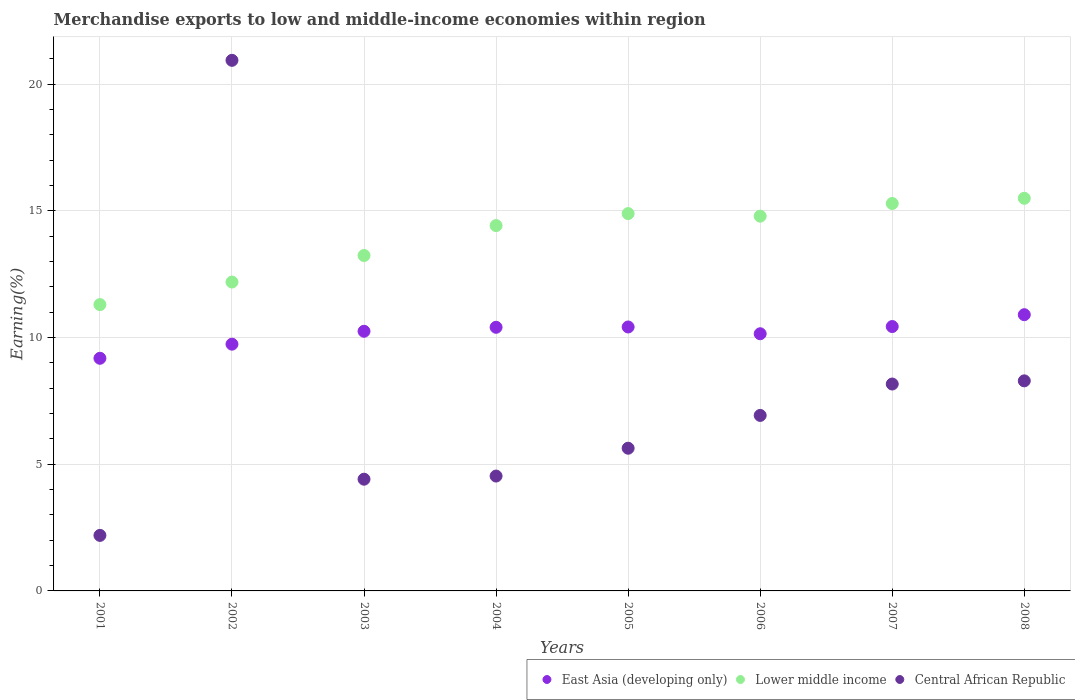How many different coloured dotlines are there?
Offer a terse response. 3. What is the percentage of amount earned from merchandise exports in Central African Republic in 2007?
Your answer should be very brief. 8.17. Across all years, what is the maximum percentage of amount earned from merchandise exports in East Asia (developing only)?
Give a very brief answer. 10.9. Across all years, what is the minimum percentage of amount earned from merchandise exports in East Asia (developing only)?
Provide a short and direct response. 9.18. What is the total percentage of amount earned from merchandise exports in Lower middle income in the graph?
Offer a very short reply. 111.63. What is the difference between the percentage of amount earned from merchandise exports in Lower middle income in 2006 and that in 2007?
Provide a succinct answer. -0.5. What is the difference between the percentage of amount earned from merchandise exports in Central African Republic in 2004 and the percentage of amount earned from merchandise exports in East Asia (developing only) in 2007?
Your answer should be very brief. -5.9. What is the average percentage of amount earned from merchandise exports in Central African Republic per year?
Your answer should be very brief. 7.64. In the year 2006, what is the difference between the percentage of amount earned from merchandise exports in Central African Republic and percentage of amount earned from merchandise exports in Lower middle income?
Make the answer very short. -7.87. In how many years, is the percentage of amount earned from merchandise exports in East Asia (developing only) greater than 20 %?
Offer a terse response. 0. What is the ratio of the percentage of amount earned from merchandise exports in Lower middle income in 2006 to that in 2008?
Ensure brevity in your answer.  0.95. What is the difference between the highest and the second highest percentage of amount earned from merchandise exports in East Asia (developing only)?
Your answer should be very brief. 0.47. What is the difference between the highest and the lowest percentage of amount earned from merchandise exports in Lower middle income?
Your answer should be compact. 4.2. In how many years, is the percentage of amount earned from merchandise exports in Central African Republic greater than the average percentage of amount earned from merchandise exports in Central African Republic taken over all years?
Offer a very short reply. 3. Is the percentage of amount earned from merchandise exports in Central African Republic strictly less than the percentage of amount earned from merchandise exports in East Asia (developing only) over the years?
Make the answer very short. No. How many dotlines are there?
Ensure brevity in your answer.  3. How many years are there in the graph?
Your answer should be compact. 8. What is the title of the graph?
Make the answer very short. Merchandise exports to low and middle-income economies within region. What is the label or title of the X-axis?
Give a very brief answer. Years. What is the label or title of the Y-axis?
Your response must be concise. Earning(%). What is the Earning(%) in East Asia (developing only) in 2001?
Provide a succinct answer. 9.18. What is the Earning(%) of Lower middle income in 2001?
Your response must be concise. 11.3. What is the Earning(%) in Central African Republic in 2001?
Ensure brevity in your answer.  2.19. What is the Earning(%) in East Asia (developing only) in 2002?
Your response must be concise. 9.74. What is the Earning(%) of Lower middle income in 2002?
Keep it short and to the point. 12.19. What is the Earning(%) in Central African Republic in 2002?
Provide a succinct answer. 20.94. What is the Earning(%) in East Asia (developing only) in 2003?
Your answer should be compact. 10.25. What is the Earning(%) in Lower middle income in 2003?
Offer a terse response. 13.24. What is the Earning(%) in Central African Republic in 2003?
Your answer should be compact. 4.41. What is the Earning(%) in East Asia (developing only) in 2004?
Ensure brevity in your answer.  10.41. What is the Earning(%) in Lower middle income in 2004?
Make the answer very short. 14.42. What is the Earning(%) in Central African Republic in 2004?
Your response must be concise. 4.53. What is the Earning(%) of East Asia (developing only) in 2005?
Give a very brief answer. 10.42. What is the Earning(%) in Lower middle income in 2005?
Your response must be concise. 14.89. What is the Earning(%) in Central African Republic in 2005?
Your response must be concise. 5.63. What is the Earning(%) in East Asia (developing only) in 2006?
Offer a terse response. 10.15. What is the Earning(%) in Lower middle income in 2006?
Your response must be concise. 14.79. What is the Earning(%) of Central African Republic in 2006?
Your answer should be very brief. 6.93. What is the Earning(%) in East Asia (developing only) in 2007?
Offer a very short reply. 10.44. What is the Earning(%) in Lower middle income in 2007?
Give a very brief answer. 15.29. What is the Earning(%) in Central African Republic in 2007?
Keep it short and to the point. 8.17. What is the Earning(%) in East Asia (developing only) in 2008?
Give a very brief answer. 10.9. What is the Earning(%) of Lower middle income in 2008?
Keep it short and to the point. 15.5. What is the Earning(%) in Central African Republic in 2008?
Provide a succinct answer. 8.29. Across all years, what is the maximum Earning(%) of East Asia (developing only)?
Offer a terse response. 10.9. Across all years, what is the maximum Earning(%) in Lower middle income?
Provide a short and direct response. 15.5. Across all years, what is the maximum Earning(%) in Central African Republic?
Make the answer very short. 20.94. Across all years, what is the minimum Earning(%) in East Asia (developing only)?
Provide a succinct answer. 9.18. Across all years, what is the minimum Earning(%) of Lower middle income?
Provide a short and direct response. 11.3. Across all years, what is the minimum Earning(%) of Central African Republic?
Ensure brevity in your answer.  2.19. What is the total Earning(%) of East Asia (developing only) in the graph?
Your answer should be very brief. 81.49. What is the total Earning(%) of Lower middle income in the graph?
Give a very brief answer. 111.63. What is the total Earning(%) in Central African Republic in the graph?
Provide a succinct answer. 61.1. What is the difference between the Earning(%) in East Asia (developing only) in 2001 and that in 2002?
Your answer should be compact. -0.56. What is the difference between the Earning(%) of Lower middle income in 2001 and that in 2002?
Make the answer very short. -0.89. What is the difference between the Earning(%) in Central African Republic in 2001 and that in 2002?
Your response must be concise. -18.75. What is the difference between the Earning(%) of East Asia (developing only) in 2001 and that in 2003?
Provide a succinct answer. -1.07. What is the difference between the Earning(%) in Lower middle income in 2001 and that in 2003?
Offer a terse response. -1.94. What is the difference between the Earning(%) in Central African Republic in 2001 and that in 2003?
Offer a terse response. -2.22. What is the difference between the Earning(%) in East Asia (developing only) in 2001 and that in 2004?
Give a very brief answer. -1.22. What is the difference between the Earning(%) in Lower middle income in 2001 and that in 2004?
Ensure brevity in your answer.  -3.12. What is the difference between the Earning(%) in Central African Republic in 2001 and that in 2004?
Your answer should be very brief. -2.34. What is the difference between the Earning(%) in East Asia (developing only) in 2001 and that in 2005?
Ensure brevity in your answer.  -1.24. What is the difference between the Earning(%) of Lower middle income in 2001 and that in 2005?
Offer a very short reply. -3.59. What is the difference between the Earning(%) in Central African Republic in 2001 and that in 2005?
Your answer should be very brief. -3.44. What is the difference between the Earning(%) of East Asia (developing only) in 2001 and that in 2006?
Provide a short and direct response. -0.97. What is the difference between the Earning(%) of Lower middle income in 2001 and that in 2006?
Give a very brief answer. -3.49. What is the difference between the Earning(%) in Central African Republic in 2001 and that in 2006?
Your response must be concise. -4.74. What is the difference between the Earning(%) in East Asia (developing only) in 2001 and that in 2007?
Your answer should be compact. -1.25. What is the difference between the Earning(%) in Lower middle income in 2001 and that in 2007?
Your answer should be very brief. -3.99. What is the difference between the Earning(%) in Central African Republic in 2001 and that in 2007?
Provide a short and direct response. -5.97. What is the difference between the Earning(%) in East Asia (developing only) in 2001 and that in 2008?
Offer a very short reply. -1.72. What is the difference between the Earning(%) of Lower middle income in 2001 and that in 2008?
Ensure brevity in your answer.  -4.2. What is the difference between the Earning(%) of Central African Republic in 2001 and that in 2008?
Provide a short and direct response. -6.1. What is the difference between the Earning(%) in East Asia (developing only) in 2002 and that in 2003?
Provide a succinct answer. -0.51. What is the difference between the Earning(%) of Lower middle income in 2002 and that in 2003?
Provide a short and direct response. -1.05. What is the difference between the Earning(%) of Central African Republic in 2002 and that in 2003?
Make the answer very short. 16.53. What is the difference between the Earning(%) of East Asia (developing only) in 2002 and that in 2004?
Offer a terse response. -0.67. What is the difference between the Earning(%) of Lower middle income in 2002 and that in 2004?
Your answer should be compact. -2.23. What is the difference between the Earning(%) in Central African Republic in 2002 and that in 2004?
Provide a short and direct response. 16.41. What is the difference between the Earning(%) of East Asia (developing only) in 2002 and that in 2005?
Give a very brief answer. -0.68. What is the difference between the Earning(%) of Lower middle income in 2002 and that in 2005?
Provide a short and direct response. -2.7. What is the difference between the Earning(%) of Central African Republic in 2002 and that in 2005?
Provide a short and direct response. 15.31. What is the difference between the Earning(%) in East Asia (developing only) in 2002 and that in 2006?
Your response must be concise. -0.41. What is the difference between the Earning(%) in Lower middle income in 2002 and that in 2006?
Offer a very short reply. -2.6. What is the difference between the Earning(%) of Central African Republic in 2002 and that in 2006?
Ensure brevity in your answer.  14.02. What is the difference between the Earning(%) in East Asia (developing only) in 2002 and that in 2007?
Offer a terse response. -0.7. What is the difference between the Earning(%) of Lower middle income in 2002 and that in 2007?
Give a very brief answer. -3.1. What is the difference between the Earning(%) of Central African Republic in 2002 and that in 2007?
Ensure brevity in your answer.  12.78. What is the difference between the Earning(%) in East Asia (developing only) in 2002 and that in 2008?
Your answer should be compact. -1.16. What is the difference between the Earning(%) of Lower middle income in 2002 and that in 2008?
Your response must be concise. -3.31. What is the difference between the Earning(%) of Central African Republic in 2002 and that in 2008?
Your answer should be compact. 12.65. What is the difference between the Earning(%) of East Asia (developing only) in 2003 and that in 2004?
Provide a short and direct response. -0.16. What is the difference between the Earning(%) in Lower middle income in 2003 and that in 2004?
Ensure brevity in your answer.  -1.18. What is the difference between the Earning(%) of Central African Republic in 2003 and that in 2004?
Your response must be concise. -0.12. What is the difference between the Earning(%) of East Asia (developing only) in 2003 and that in 2005?
Provide a succinct answer. -0.17. What is the difference between the Earning(%) in Lower middle income in 2003 and that in 2005?
Ensure brevity in your answer.  -1.65. What is the difference between the Earning(%) in Central African Republic in 2003 and that in 2005?
Your answer should be compact. -1.22. What is the difference between the Earning(%) in East Asia (developing only) in 2003 and that in 2006?
Keep it short and to the point. 0.1. What is the difference between the Earning(%) of Lower middle income in 2003 and that in 2006?
Offer a very short reply. -1.55. What is the difference between the Earning(%) in Central African Republic in 2003 and that in 2006?
Make the answer very short. -2.52. What is the difference between the Earning(%) of East Asia (developing only) in 2003 and that in 2007?
Provide a short and direct response. -0.19. What is the difference between the Earning(%) in Lower middle income in 2003 and that in 2007?
Offer a terse response. -2.05. What is the difference between the Earning(%) of Central African Republic in 2003 and that in 2007?
Provide a succinct answer. -3.76. What is the difference between the Earning(%) of East Asia (developing only) in 2003 and that in 2008?
Provide a succinct answer. -0.65. What is the difference between the Earning(%) in Lower middle income in 2003 and that in 2008?
Offer a terse response. -2.26. What is the difference between the Earning(%) of Central African Republic in 2003 and that in 2008?
Make the answer very short. -3.88. What is the difference between the Earning(%) of East Asia (developing only) in 2004 and that in 2005?
Offer a very short reply. -0.01. What is the difference between the Earning(%) of Lower middle income in 2004 and that in 2005?
Offer a terse response. -0.47. What is the difference between the Earning(%) of Central African Republic in 2004 and that in 2005?
Provide a short and direct response. -1.1. What is the difference between the Earning(%) of East Asia (developing only) in 2004 and that in 2006?
Provide a short and direct response. 0.25. What is the difference between the Earning(%) of Lower middle income in 2004 and that in 2006?
Make the answer very short. -0.37. What is the difference between the Earning(%) in Central African Republic in 2004 and that in 2006?
Your response must be concise. -2.39. What is the difference between the Earning(%) in East Asia (developing only) in 2004 and that in 2007?
Ensure brevity in your answer.  -0.03. What is the difference between the Earning(%) of Lower middle income in 2004 and that in 2007?
Ensure brevity in your answer.  -0.87. What is the difference between the Earning(%) of Central African Republic in 2004 and that in 2007?
Keep it short and to the point. -3.63. What is the difference between the Earning(%) in East Asia (developing only) in 2004 and that in 2008?
Offer a very short reply. -0.5. What is the difference between the Earning(%) of Lower middle income in 2004 and that in 2008?
Provide a succinct answer. -1.08. What is the difference between the Earning(%) of Central African Republic in 2004 and that in 2008?
Your answer should be very brief. -3.76. What is the difference between the Earning(%) in East Asia (developing only) in 2005 and that in 2006?
Offer a very short reply. 0.27. What is the difference between the Earning(%) of Lower middle income in 2005 and that in 2006?
Make the answer very short. 0.1. What is the difference between the Earning(%) in Central African Republic in 2005 and that in 2006?
Provide a succinct answer. -1.29. What is the difference between the Earning(%) of East Asia (developing only) in 2005 and that in 2007?
Ensure brevity in your answer.  -0.02. What is the difference between the Earning(%) of Lower middle income in 2005 and that in 2007?
Keep it short and to the point. -0.4. What is the difference between the Earning(%) of Central African Republic in 2005 and that in 2007?
Your response must be concise. -2.53. What is the difference between the Earning(%) of East Asia (developing only) in 2005 and that in 2008?
Provide a short and direct response. -0.48. What is the difference between the Earning(%) in Lower middle income in 2005 and that in 2008?
Provide a succinct answer. -0.6. What is the difference between the Earning(%) in Central African Republic in 2005 and that in 2008?
Your response must be concise. -2.66. What is the difference between the Earning(%) in East Asia (developing only) in 2006 and that in 2007?
Your response must be concise. -0.28. What is the difference between the Earning(%) of Lower middle income in 2006 and that in 2007?
Offer a terse response. -0.5. What is the difference between the Earning(%) in Central African Republic in 2006 and that in 2007?
Provide a short and direct response. -1.24. What is the difference between the Earning(%) of East Asia (developing only) in 2006 and that in 2008?
Offer a terse response. -0.75. What is the difference between the Earning(%) of Lower middle income in 2006 and that in 2008?
Ensure brevity in your answer.  -0.71. What is the difference between the Earning(%) in Central African Republic in 2006 and that in 2008?
Offer a very short reply. -1.36. What is the difference between the Earning(%) in East Asia (developing only) in 2007 and that in 2008?
Provide a succinct answer. -0.47. What is the difference between the Earning(%) of Lower middle income in 2007 and that in 2008?
Ensure brevity in your answer.  -0.21. What is the difference between the Earning(%) in Central African Republic in 2007 and that in 2008?
Give a very brief answer. -0.13. What is the difference between the Earning(%) in East Asia (developing only) in 2001 and the Earning(%) in Lower middle income in 2002?
Your answer should be compact. -3.01. What is the difference between the Earning(%) in East Asia (developing only) in 2001 and the Earning(%) in Central African Republic in 2002?
Give a very brief answer. -11.76. What is the difference between the Earning(%) in Lower middle income in 2001 and the Earning(%) in Central African Republic in 2002?
Offer a terse response. -9.64. What is the difference between the Earning(%) of East Asia (developing only) in 2001 and the Earning(%) of Lower middle income in 2003?
Make the answer very short. -4.06. What is the difference between the Earning(%) in East Asia (developing only) in 2001 and the Earning(%) in Central African Republic in 2003?
Make the answer very short. 4.77. What is the difference between the Earning(%) of Lower middle income in 2001 and the Earning(%) of Central African Republic in 2003?
Ensure brevity in your answer.  6.89. What is the difference between the Earning(%) in East Asia (developing only) in 2001 and the Earning(%) in Lower middle income in 2004?
Keep it short and to the point. -5.24. What is the difference between the Earning(%) in East Asia (developing only) in 2001 and the Earning(%) in Central African Republic in 2004?
Offer a very short reply. 4.65. What is the difference between the Earning(%) in Lower middle income in 2001 and the Earning(%) in Central African Republic in 2004?
Provide a succinct answer. 6.77. What is the difference between the Earning(%) of East Asia (developing only) in 2001 and the Earning(%) of Lower middle income in 2005?
Provide a short and direct response. -5.71. What is the difference between the Earning(%) of East Asia (developing only) in 2001 and the Earning(%) of Central African Republic in 2005?
Provide a short and direct response. 3.55. What is the difference between the Earning(%) in Lower middle income in 2001 and the Earning(%) in Central African Republic in 2005?
Your response must be concise. 5.67. What is the difference between the Earning(%) in East Asia (developing only) in 2001 and the Earning(%) in Lower middle income in 2006?
Ensure brevity in your answer.  -5.61. What is the difference between the Earning(%) in East Asia (developing only) in 2001 and the Earning(%) in Central African Republic in 2006?
Give a very brief answer. 2.26. What is the difference between the Earning(%) of Lower middle income in 2001 and the Earning(%) of Central African Republic in 2006?
Your response must be concise. 4.37. What is the difference between the Earning(%) of East Asia (developing only) in 2001 and the Earning(%) of Lower middle income in 2007?
Your response must be concise. -6.11. What is the difference between the Earning(%) in East Asia (developing only) in 2001 and the Earning(%) in Central African Republic in 2007?
Offer a terse response. 1.02. What is the difference between the Earning(%) of Lower middle income in 2001 and the Earning(%) of Central African Republic in 2007?
Your answer should be compact. 3.14. What is the difference between the Earning(%) in East Asia (developing only) in 2001 and the Earning(%) in Lower middle income in 2008?
Ensure brevity in your answer.  -6.32. What is the difference between the Earning(%) of East Asia (developing only) in 2001 and the Earning(%) of Central African Republic in 2008?
Your answer should be compact. 0.89. What is the difference between the Earning(%) in Lower middle income in 2001 and the Earning(%) in Central African Republic in 2008?
Offer a very short reply. 3.01. What is the difference between the Earning(%) of East Asia (developing only) in 2002 and the Earning(%) of Lower middle income in 2003?
Make the answer very short. -3.5. What is the difference between the Earning(%) in East Asia (developing only) in 2002 and the Earning(%) in Central African Republic in 2003?
Ensure brevity in your answer.  5.33. What is the difference between the Earning(%) of Lower middle income in 2002 and the Earning(%) of Central African Republic in 2003?
Your response must be concise. 7.78. What is the difference between the Earning(%) of East Asia (developing only) in 2002 and the Earning(%) of Lower middle income in 2004?
Your response must be concise. -4.68. What is the difference between the Earning(%) in East Asia (developing only) in 2002 and the Earning(%) in Central African Republic in 2004?
Offer a very short reply. 5.21. What is the difference between the Earning(%) of Lower middle income in 2002 and the Earning(%) of Central African Republic in 2004?
Offer a very short reply. 7.66. What is the difference between the Earning(%) of East Asia (developing only) in 2002 and the Earning(%) of Lower middle income in 2005?
Offer a very short reply. -5.15. What is the difference between the Earning(%) in East Asia (developing only) in 2002 and the Earning(%) in Central African Republic in 2005?
Make the answer very short. 4.11. What is the difference between the Earning(%) of Lower middle income in 2002 and the Earning(%) of Central African Republic in 2005?
Provide a short and direct response. 6.56. What is the difference between the Earning(%) of East Asia (developing only) in 2002 and the Earning(%) of Lower middle income in 2006?
Your answer should be compact. -5.05. What is the difference between the Earning(%) in East Asia (developing only) in 2002 and the Earning(%) in Central African Republic in 2006?
Keep it short and to the point. 2.81. What is the difference between the Earning(%) of Lower middle income in 2002 and the Earning(%) of Central African Republic in 2006?
Your response must be concise. 5.26. What is the difference between the Earning(%) of East Asia (developing only) in 2002 and the Earning(%) of Lower middle income in 2007?
Keep it short and to the point. -5.55. What is the difference between the Earning(%) of East Asia (developing only) in 2002 and the Earning(%) of Central African Republic in 2007?
Ensure brevity in your answer.  1.57. What is the difference between the Earning(%) of Lower middle income in 2002 and the Earning(%) of Central African Republic in 2007?
Your response must be concise. 4.03. What is the difference between the Earning(%) of East Asia (developing only) in 2002 and the Earning(%) of Lower middle income in 2008?
Your answer should be compact. -5.76. What is the difference between the Earning(%) of East Asia (developing only) in 2002 and the Earning(%) of Central African Republic in 2008?
Offer a very short reply. 1.45. What is the difference between the Earning(%) in Lower middle income in 2002 and the Earning(%) in Central African Republic in 2008?
Provide a short and direct response. 3.9. What is the difference between the Earning(%) of East Asia (developing only) in 2003 and the Earning(%) of Lower middle income in 2004?
Keep it short and to the point. -4.17. What is the difference between the Earning(%) of East Asia (developing only) in 2003 and the Earning(%) of Central African Republic in 2004?
Offer a terse response. 5.72. What is the difference between the Earning(%) of Lower middle income in 2003 and the Earning(%) of Central African Republic in 2004?
Provide a short and direct response. 8.71. What is the difference between the Earning(%) in East Asia (developing only) in 2003 and the Earning(%) in Lower middle income in 2005?
Your answer should be very brief. -4.64. What is the difference between the Earning(%) of East Asia (developing only) in 2003 and the Earning(%) of Central African Republic in 2005?
Give a very brief answer. 4.62. What is the difference between the Earning(%) of Lower middle income in 2003 and the Earning(%) of Central African Republic in 2005?
Ensure brevity in your answer.  7.61. What is the difference between the Earning(%) in East Asia (developing only) in 2003 and the Earning(%) in Lower middle income in 2006?
Offer a terse response. -4.54. What is the difference between the Earning(%) in East Asia (developing only) in 2003 and the Earning(%) in Central African Republic in 2006?
Your answer should be very brief. 3.32. What is the difference between the Earning(%) in Lower middle income in 2003 and the Earning(%) in Central African Republic in 2006?
Your response must be concise. 6.31. What is the difference between the Earning(%) of East Asia (developing only) in 2003 and the Earning(%) of Lower middle income in 2007?
Give a very brief answer. -5.04. What is the difference between the Earning(%) in East Asia (developing only) in 2003 and the Earning(%) in Central African Republic in 2007?
Provide a short and direct response. 2.08. What is the difference between the Earning(%) in Lower middle income in 2003 and the Earning(%) in Central African Republic in 2007?
Your answer should be very brief. 5.07. What is the difference between the Earning(%) of East Asia (developing only) in 2003 and the Earning(%) of Lower middle income in 2008?
Keep it short and to the point. -5.25. What is the difference between the Earning(%) of East Asia (developing only) in 2003 and the Earning(%) of Central African Republic in 2008?
Ensure brevity in your answer.  1.96. What is the difference between the Earning(%) in Lower middle income in 2003 and the Earning(%) in Central African Republic in 2008?
Provide a succinct answer. 4.95. What is the difference between the Earning(%) in East Asia (developing only) in 2004 and the Earning(%) in Lower middle income in 2005?
Your answer should be very brief. -4.49. What is the difference between the Earning(%) in East Asia (developing only) in 2004 and the Earning(%) in Central African Republic in 2005?
Offer a terse response. 4.77. What is the difference between the Earning(%) of Lower middle income in 2004 and the Earning(%) of Central African Republic in 2005?
Keep it short and to the point. 8.79. What is the difference between the Earning(%) of East Asia (developing only) in 2004 and the Earning(%) of Lower middle income in 2006?
Provide a succinct answer. -4.39. What is the difference between the Earning(%) of East Asia (developing only) in 2004 and the Earning(%) of Central African Republic in 2006?
Ensure brevity in your answer.  3.48. What is the difference between the Earning(%) of Lower middle income in 2004 and the Earning(%) of Central African Republic in 2006?
Offer a very short reply. 7.49. What is the difference between the Earning(%) of East Asia (developing only) in 2004 and the Earning(%) of Lower middle income in 2007?
Your answer should be compact. -4.89. What is the difference between the Earning(%) of East Asia (developing only) in 2004 and the Earning(%) of Central African Republic in 2007?
Offer a terse response. 2.24. What is the difference between the Earning(%) in Lower middle income in 2004 and the Earning(%) in Central African Republic in 2007?
Your answer should be very brief. 6.25. What is the difference between the Earning(%) of East Asia (developing only) in 2004 and the Earning(%) of Lower middle income in 2008?
Give a very brief answer. -5.09. What is the difference between the Earning(%) in East Asia (developing only) in 2004 and the Earning(%) in Central African Republic in 2008?
Offer a very short reply. 2.11. What is the difference between the Earning(%) of Lower middle income in 2004 and the Earning(%) of Central African Republic in 2008?
Provide a succinct answer. 6.13. What is the difference between the Earning(%) of East Asia (developing only) in 2005 and the Earning(%) of Lower middle income in 2006?
Ensure brevity in your answer.  -4.37. What is the difference between the Earning(%) of East Asia (developing only) in 2005 and the Earning(%) of Central African Republic in 2006?
Your answer should be very brief. 3.49. What is the difference between the Earning(%) in Lower middle income in 2005 and the Earning(%) in Central African Republic in 2006?
Provide a short and direct response. 7.97. What is the difference between the Earning(%) of East Asia (developing only) in 2005 and the Earning(%) of Lower middle income in 2007?
Make the answer very short. -4.87. What is the difference between the Earning(%) of East Asia (developing only) in 2005 and the Earning(%) of Central African Republic in 2007?
Keep it short and to the point. 2.25. What is the difference between the Earning(%) of Lower middle income in 2005 and the Earning(%) of Central African Republic in 2007?
Offer a very short reply. 6.73. What is the difference between the Earning(%) in East Asia (developing only) in 2005 and the Earning(%) in Lower middle income in 2008?
Your response must be concise. -5.08. What is the difference between the Earning(%) in East Asia (developing only) in 2005 and the Earning(%) in Central African Republic in 2008?
Your answer should be very brief. 2.13. What is the difference between the Earning(%) in Lower middle income in 2005 and the Earning(%) in Central African Republic in 2008?
Your answer should be compact. 6.6. What is the difference between the Earning(%) of East Asia (developing only) in 2006 and the Earning(%) of Lower middle income in 2007?
Ensure brevity in your answer.  -5.14. What is the difference between the Earning(%) of East Asia (developing only) in 2006 and the Earning(%) of Central African Republic in 2007?
Your answer should be very brief. 1.98. What is the difference between the Earning(%) in Lower middle income in 2006 and the Earning(%) in Central African Republic in 2007?
Offer a terse response. 6.63. What is the difference between the Earning(%) in East Asia (developing only) in 2006 and the Earning(%) in Lower middle income in 2008?
Ensure brevity in your answer.  -5.35. What is the difference between the Earning(%) in East Asia (developing only) in 2006 and the Earning(%) in Central African Republic in 2008?
Provide a succinct answer. 1.86. What is the difference between the Earning(%) in Lower middle income in 2006 and the Earning(%) in Central African Republic in 2008?
Provide a short and direct response. 6.5. What is the difference between the Earning(%) in East Asia (developing only) in 2007 and the Earning(%) in Lower middle income in 2008?
Keep it short and to the point. -5.06. What is the difference between the Earning(%) in East Asia (developing only) in 2007 and the Earning(%) in Central African Republic in 2008?
Provide a succinct answer. 2.14. What is the difference between the Earning(%) in Lower middle income in 2007 and the Earning(%) in Central African Republic in 2008?
Provide a succinct answer. 7. What is the average Earning(%) in East Asia (developing only) per year?
Your answer should be very brief. 10.19. What is the average Earning(%) in Lower middle income per year?
Ensure brevity in your answer.  13.95. What is the average Earning(%) of Central African Republic per year?
Your response must be concise. 7.64. In the year 2001, what is the difference between the Earning(%) of East Asia (developing only) and Earning(%) of Lower middle income?
Your answer should be very brief. -2.12. In the year 2001, what is the difference between the Earning(%) of East Asia (developing only) and Earning(%) of Central African Republic?
Your answer should be very brief. 6.99. In the year 2001, what is the difference between the Earning(%) of Lower middle income and Earning(%) of Central African Republic?
Provide a succinct answer. 9.11. In the year 2002, what is the difference between the Earning(%) in East Asia (developing only) and Earning(%) in Lower middle income?
Offer a very short reply. -2.45. In the year 2002, what is the difference between the Earning(%) of East Asia (developing only) and Earning(%) of Central African Republic?
Ensure brevity in your answer.  -11.2. In the year 2002, what is the difference between the Earning(%) in Lower middle income and Earning(%) in Central African Republic?
Your answer should be compact. -8.75. In the year 2003, what is the difference between the Earning(%) of East Asia (developing only) and Earning(%) of Lower middle income?
Your answer should be very brief. -2.99. In the year 2003, what is the difference between the Earning(%) in East Asia (developing only) and Earning(%) in Central African Republic?
Provide a succinct answer. 5.84. In the year 2003, what is the difference between the Earning(%) in Lower middle income and Earning(%) in Central African Republic?
Provide a succinct answer. 8.83. In the year 2004, what is the difference between the Earning(%) in East Asia (developing only) and Earning(%) in Lower middle income?
Offer a very short reply. -4.01. In the year 2004, what is the difference between the Earning(%) of East Asia (developing only) and Earning(%) of Central African Republic?
Make the answer very short. 5.87. In the year 2004, what is the difference between the Earning(%) in Lower middle income and Earning(%) in Central African Republic?
Your answer should be compact. 9.89. In the year 2005, what is the difference between the Earning(%) in East Asia (developing only) and Earning(%) in Lower middle income?
Keep it short and to the point. -4.48. In the year 2005, what is the difference between the Earning(%) in East Asia (developing only) and Earning(%) in Central African Republic?
Offer a very short reply. 4.79. In the year 2005, what is the difference between the Earning(%) in Lower middle income and Earning(%) in Central African Republic?
Provide a short and direct response. 9.26. In the year 2006, what is the difference between the Earning(%) of East Asia (developing only) and Earning(%) of Lower middle income?
Provide a short and direct response. -4.64. In the year 2006, what is the difference between the Earning(%) of East Asia (developing only) and Earning(%) of Central African Republic?
Make the answer very short. 3.22. In the year 2006, what is the difference between the Earning(%) of Lower middle income and Earning(%) of Central African Republic?
Give a very brief answer. 7.87. In the year 2007, what is the difference between the Earning(%) in East Asia (developing only) and Earning(%) in Lower middle income?
Your response must be concise. -4.86. In the year 2007, what is the difference between the Earning(%) of East Asia (developing only) and Earning(%) of Central African Republic?
Your response must be concise. 2.27. In the year 2007, what is the difference between the Earning(%) of Lower middle income and Earning(%) of Central African Republic?
Your answer should be very brief. 7.13. In the year 2008, what is the difference between the Earning(%) in East Asia (developing only) and Earning(%) in Lower middle income?
Offer a very short reply. -4.6. In the year 2008, what is the difference between the Earning(%) of East Asia (developing only) and Earning(%) of Central African Republic?
Give a very brief answer. 2.61. In the year 2008, what is the difference between the Earning(%) in Lower middle income and Earning(%) in Central African Republic?
Provide a short and direct response. 7.21. What is the ratio of the Earning(%) of East Asia (developing only) in 2001 to that in 2002?
Make the answer very short. 0.94. What is the ratio of the Earning(%) of Lower middle income in 2001 to that in 2002?
Keep it short and to the point. 0.93. What is the ratio of the Earning(%) in Central African Republic in 2001 to that in 2002?
Your response must be concise. 0.1. What is the ratio of the Earning(%) in East Asia (developing only) in 2001 to that in 2003?
Your response must be concise. 0.9. What is the ratio of the Earning(%) in Lower middle income in 2001 to that in 2003?
Your answer should be compact. 0.85. What is the ratio of the Earning(%) of Central African Republic in 2001 to that in 2003?
Ensure brevity in your answer.  0.5. What is the ratio of the Earning(%) in East Asia (developing only) in 2001 to that in 2004?
Keep it short and to the point. 0.88. What is the ratio of the Earning(%) in Lower middle income in 2001 to that in 2004?
Make the answer very short. 0.78. What is the ratio of the Earning(%) of Central African Republic in 2001 to that in 2004?
Provide a short and direct response. 0.48. What is the ratio of the Earning(%) of East Asia (developing only) in 2001 to that in 2005?
Your answer should be very brief. 0.88. What is the ratio of the Earning(%) of Lower middle income in 2001 to that in 2005?
Make the answer very short. 0.76. What is the ratio of the Earning(%) in Central African Republic in 2001 to that in 2005?
Provide a succinct answer. 0.39. What is the ratio of the Earning(%) of East Asia (developing only) in 2001 to that in 2006?
Provide a succinct answer. 0.9. What is the ratio of the Earning(%) of Lower middle income in 2001 to that in 2006?
Your response must be concise. 0.76. What is the ratio of the Earning(%) of Central African Republic in 2001 to that in 2006?
Keep it short and to the point. 0.32. What is the ratio of the Earning(%) of East Asia (developing only) in 2001 to that in 2007?
Your answer should be very brief. 0.88. What is the ratio of the Earning(%) in Lower middle income in 2001 to that in 2007?
Offer a very short reply. 0.74. What is the ratio of the Earning(%) in Central African Republic in 2001 to that in 2007?
Give a very brief answer. 0.27. What is the ratio of the Earning(%) in East Asia (developing only) in 2001 to that in 2008?
Offer a very short reply. 0.84. What is the ratio of the Earning(%) of Lower middle income in 2001 to that in 2008?
Offer a terse response. 0.73. What is the ratio of the Earning(%) in Central African Republic in 2001 to that in 2008?
Give a very brief answer. 0.26. What is the ratio of the Earning(%) of East Asia (developing only) in 2002 to that in 2003?
Your answer should be very brief. 0.95. What is the ratio of the Earning(%) in Lower middle income in 2002 to that in 2003?
Provide a succinct answer. 0.92. What is the ratio of the Earning(%) in Central African Republic in 2002 to that in 2003?
Your answer should be compact. 4.75. What is the ratio of the Earning(%) in East Asia (developing only) in 2002 to that in 2004?
Provide a short and direct response. 0.94. What is the ratio of the Earning(%) of Lower middle income in 2002 to that in 2004?
Provide a succinct answer. 0.85. What is the ratio of the Earning(%) of Central African Republic in 2002 to that in 2004?
Provide a short and direct response. 4.62. What is the ratio of the Earning(%) in East Asia (developing only) in 2002 to that in 2005?
Provide a short and direct response. 0.93. What is the ratio of the Earning(%) of Lower middle income in 2002 to that in 2005?
Ensure brevity in your answer.  0.82. What is the ratio of the Earning(%) in Central African Republic in 2002 to that in 2005?
Give a very brief answer. 3.72. What is the ratio of the Earning(%) of East Asia (developing only) in 2002 to that in 2006?
Make the answer very short. 0.96. What is the ratio of the Earning(%) of Lower middle income in 2002 to that in 2006?
Ensure brevity in your answer.  0.82. What is the ratio of the Earning(%) in Central African Republic in 2002 to that in 2006?
Provide a succinct answer. 3.02. What is the ratio of the Earning(%) of East Asia (developing only) in 2002 to that in 2007?
Ensure brevity in your answer.  0.93. What is the ratio of the Earning(%) in Lower middle income in 2002 to that in 2007?
Give a very brief answer. 0.8. What is the ratio of the Earning(%) in Central African Republic in 2002 to that in 2007?
Your answer should be compact. 2.56. What is the ratio of the Earning(%) in East Asia (developing only) in 2002 to that in 2008?
Offer a terse response. 0.89. What is the ratio of the Earning(%) of Lower middle income in 2002 to that in 2008?
Provide a succinct answer. 0.79. What is the ratio of the Earning(%) in Central African Republic in 2002 to that in 2008?
Provide a short and direct response. 2.53. What is the ratio of the Earning(%) in East Asia (developing only) in 2003 to that in 2004?
Give a very brief answer. 0.98. What is the ratio of the Earning(%) of Lower middle income in 2003 to that in 2004?
Your response must be concise. 0.92. What is the ratio of the Earning(%) in Central African Republic in 2003 to that in 2004?
Offer a terse response. 0.97. What is the ratio of the Earning(%) in East Asia (developing only) in 2003 to that in 2005?
Make the answer very short. 0.98. What is the ratio of the Earning(%) in Central African Republic in 2003 to that in 2005?
Offer a terse response. 0.78. What is the ratio of the Earning(%) in East Asia (developing only) in 2003 to that in 2006?
Offer a very short reply. 1.01. What is the ratio of the Earning(%) in Lower middle income in 2003 to that in 2006?
Ensure brevity in your answer.  0.9. What is the ratio of the Earning(%) in Central African Republic in 2003 to that in 2006?
Your response must be concise. 0.64. What is the ratio of the Earning(%) of East Asia (developing only) in 2003 to that in 2007?
Offer a very short reply. 0.98. What is the ratio of the Earning(%) in Lower middle income in 2003 to that in 2007?
Make the answer very short. 0.87. What is the ratio of the Earning(%) of Central African Republic in 2003 to that in 2007?
Your answer should be compact. 0.54. What is the ratio of the Earning(%) in East Asia (developing only) in 2003 to that in 2008?
Keep it short and to the point. 0.94. What is the ratio of the Earning(%) of Lower middle income in 2003 to that in 2008?
Give a very brief answer. 0.85. What is the ratio of the Earning(%) of Central African Republic in 2003 to that in 2008?
Keep it short and to the point. 0.53. What is the ratio of the Earning(%) in East Asia (developing only) in 2004 to that in 2005?
Offer a very short reply. 1. What is the ratio of the Earning(%) in Lower middle income in 2004 to that in 2005?
Your answer should be very brief. 0.97. What is the ratio of the Earning(%) in Central African Republic in 2004 to that in 2005?
Your response must be concise. 0.81. What is the ratio of the Earning(%) of East Asia (developing only) in 2004 to that in 2006?
Provide a short and direct response. 1.03. What is the ratio of the Earning(%) in Lower middle income in 2004 to that in 2006?
Offer a very short reply. 0.97. What is the ratio of the Earning(%) in Central African Republic in 2004 to that in 2006?
Provide a short and direct response. 0.65. What is the ratio of the Earning(%) of East Asia (developing only) in 2004 to that in 2007?
Offer a terse response. 1. What is the ratio of the Earning(%) of Lower middle income in 2004 to that in 2007?
Give a very brief answer. 0.94. What is the ratio of the Earning(%) in Central African Republic in 2004 to that in 2007?
Ensure brevity in your answer.  0.56. What is the ratio of the Earning(%) of East Asia (developing only) in 2004 to that in 2008?
Your answer should be compact. 0.95. What is the ratio of the Earning(%) in Lower middle income in 2004 to that in 2008?
Provide a short and direct response. 0.93. What is the ratio of the Earning(%) of Central African Republic in 2004 to that in 2008?
Provide a short and direct response. 0.55. What is the ratio of the Earning(%) in East Asia (developing only) in 2005 to that in 2006?
Offer a very short reply. 1.03. What is the ratio of the Earning(%) of Central African Republic in 2005 to that in 2006?
Your answer should be compact. 0.81. What is the ratio of the Earning(%) in Lower middle income in 2005 to that in 2007?
Give a very brief answer. 0.97. What is the ratio of the Earning(%) of Central African Republic in 2005 to that in 2007?
Your response must be concise. 0.69. What is the ratio of the Earning(%) of East Asia (developing only) in 2005 to that in 2008?
Offer a very short reply. 0.96. What is the ratio of the Earning(%) of Lower middle income in 2005 to that in 2008?
Offer a very short reply. 0.96. What is the ratio of the Earning(%) of Central African Republic in 2005 to that in 2008?
Ensure brevity in your answer.  0.68. What is the ratio of the Earning(%) of East Asia (developing only) in 2006 to that in 2007?
Provide a succinct answer. 0.97. What is the ratio of the Earning(%) of Lower middle income in 2006 to that in 2007?
Offer a very short reply. 0.97. What is the ratio of the Earning(%) of Central African Republic in 2006 to that in 2007?
Your answer should be compact. 0.85. What is the ratio of the Earning(%) of East Asia (developing only) in 2006 to that in 2008?
Give a very brief answer. 0.93. What is the ratio of the Earning(%) in Lower middle income in 2006 to that in 2008?
Provide a short and direct response. 0.95. What is the ratio of the Earning(%) of Central African Republic in 2006 to that in 2008?
Make the answer very short. 0.84. What is the ratio of the Earning(%) of East Asia (developing only) in 2007 to that in 2008?
Offer a very short reply. 0.96. What is the ratio of the Earning(%) of Lower middle income in 2007 to that in 2008?
Provide a short and direct response. 0.99. What is the ratio of the Earning(%) of Central African Republic in 2007 to that in 2008?
Provide a short and direct response. 0.98. What is the difference between the highest and the second highest Earning(%) in East Asia (developing only)?
Your answer should be compact. 0.47. What is the difference between the highest and the second highest Earning(%) of Lower middle income?
Provide a short and direct response. 0.21. What is the difference between the highest and the second highest Earning(%) in Central African Republic?
Your answer should be compact. 12.65. What is the difference between the highest and the lowest Earning(%) in East Asia (developing only)?
Provide a succinct answer. 1.72. What is the difference between the highest and the lowest Earning(%) in Lower middle income?
Your answer should be compact. 4.2. What is the difference between the highest and the lowest Earning(%) in Central African Republic?
Offer a very short reply. 18.75. 